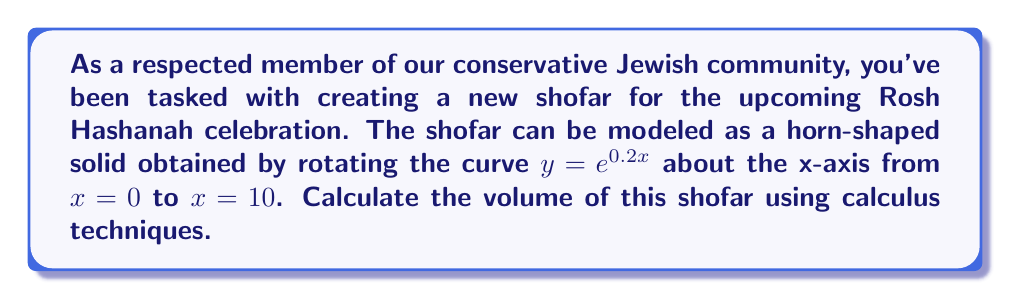What is the answer to this math problem? To solve this problem, we'll use the method of volumes by rotation, specifically the shell method. The steps are as follows:

1) The shell method formula for volume is:

   $$V = 2\pi \int_a^b y \cdot x \, dx$$

   where $y$ is the function and $x$ is the distance from the axis of rotation.

2) In our case, $y = e^{0.2x}$, $a = 0$, and $b = 10$.

3) Substituting these into our formula:

   $$V = 2\pi \int_0^{10} e^{0.2x} \cdot x \, dx$$

4) To integrate this, we'll use integration by parts. Let $u = x$ and $dv = e^{0.2x} dx$.
   Then $du = dx$ and $v = \frac{1}{0.2}e^{0.2x}$.

5) Applying the integration by parts formula:

   $$V = 2\pi \left[ \frac{x}{0.2}e^{0.2x} \bigg|_0^{10} - \int_0^{10} \frac{1}{0.2}e^{0.2x} dx \right]$$

6) Evaluating the first part:

   $$\frac{x}{0.2}e^{0.2x} \bigg|_0^{10} = 50e^2 - 0$$

7) For the second part:

   $$\int_0^{10} \frac{1}{0.2}e^{0.2x} dx = 5e^{0.2x} \bigg|_0^{10} = 5e^2 - 5$$

8) Putting it all together:

   $$V = 2\pi \left[ 50e^2 - (5e^2 - 5) \right] = 2\pi(45e^2 + 5)$$

9) Simplifying:

   $$V = 90\pi e^2 + 10\pi$$

This gives us the volume of the shofar in cubic units.
Answer: $90\pi e^2 + 10\pi$ cubic units 